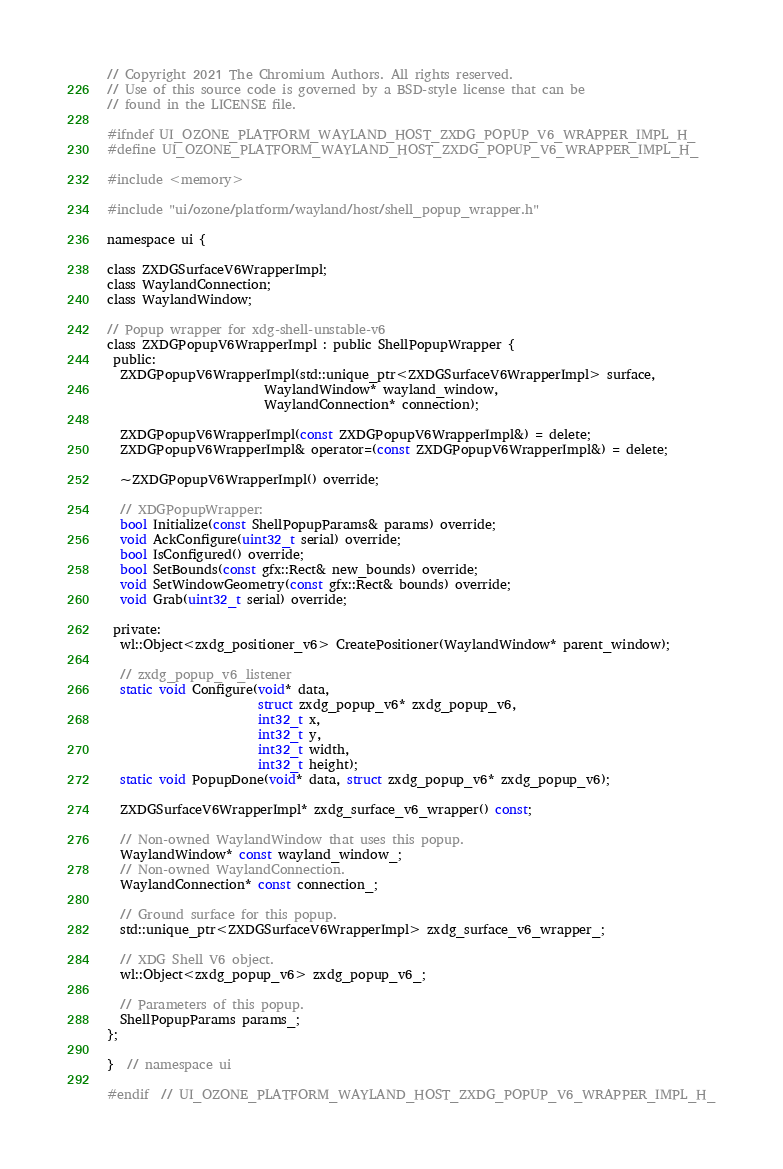Convert code to text. <code><loc_0><loc_0><loc_500><loc_500><_C_>// Copyright 2021 The Chromium Authors. All rights reserved.
// Use of this source code is governed by a BSD-style license that can be
// found in the LICENSE file.

#ifndef UI_OZONE_PLATFORM_WAYLAND_HOST_ZXDG_POPUP_V6_WRAPPER_IMPL_H_
#define UI_OZONE_PLATFORM_WAYLAND_HOST_ZXDG_POPUP_V6_WRAPPER_IMPL_H_

#include <memory>

#include "ui/ozone/platform/wayland/host/shell_popup_wrapper.h"

namespace ui {

class ZXDGSurfaceV6WrapperImpl;
class WaylandConnection;
class WaylandWindow;

// Popup wrapper for xdg-shell-unstable-v6
class ZXDGPopupV6WrapperImpl : public ShellPopupWrapper {
 public:
  ZXDGPopupV6WrapperImpl(std::unique_ptr<ZXDGSurfaceV6WrapperImpl> surface,
                         WaylandWindow* wayland_window,
                         WaylandConnection* connection);

  ZXDGPopupV6WrapperImpl(const ZXDGPopupV6WrapperImpl&) = delete;
  ZXDGPopupV6WrapperImpl& operator=(const ZXDGPopupV6WrapperImpl&) = delete;

  ~ZXDGPopupV6WrapperImpl() override;

  // XDGPopupWrapper:
  bool Initialize(const ShellPopupParams& params) override;
  void AckConfigure(uint32_t serial) override;
  bool IsConfigured() override;
  bool SetBounds(const gfx::Rect& new_bounds) override;
  void SetWindowGeometry(const gfx::Rect& bounds) override;
  void Grab(uint32_t serial) override;

 private:
  wl::Object<zxdg_positioner_v6> CreatePositioner(WaylandWindow* parent_window);

  // zxdg_popup_v6_listener
  static void Configure(void* data,
                        struct zxdg_popup_v6* zxdg_popup_v6,
                        int32_t x,
                        int32_t y,
                        int32_t width,
                        int32_t height);
  static void PopupDone(void* data, struct zxdg_popup_v6* zxdg_popup_v6);

  ZXDGSurfaceV6WrapperImpl* zxdg_surface_v6_wrapper() const;

  // Non-owned WaylandWindow that uses this popup.
  WaylandWindow* const wayland_window_;
  // Non-owned WaylandConnection.
  WaylandConnection* const connection_;

  // Ground surface for this popup.
  std::unique_ptr<ZXDGSurfaceV6WrapperImpl> zxdg_surface_v6_wrapper_;

  // XDG Shell V6 object.
  wl::Object<zxdg_popup_v6> zxdg_popup_v6_;

  // Parameters of this popup.
  ShellPopupParams params_;
};

}  // namespace ui

#endif  // UI_OZONE_PLATFORM_WAYLAND_HOST_ZXDG_POPUP_V6_WRAPPER_IMPL_H_
</code> 